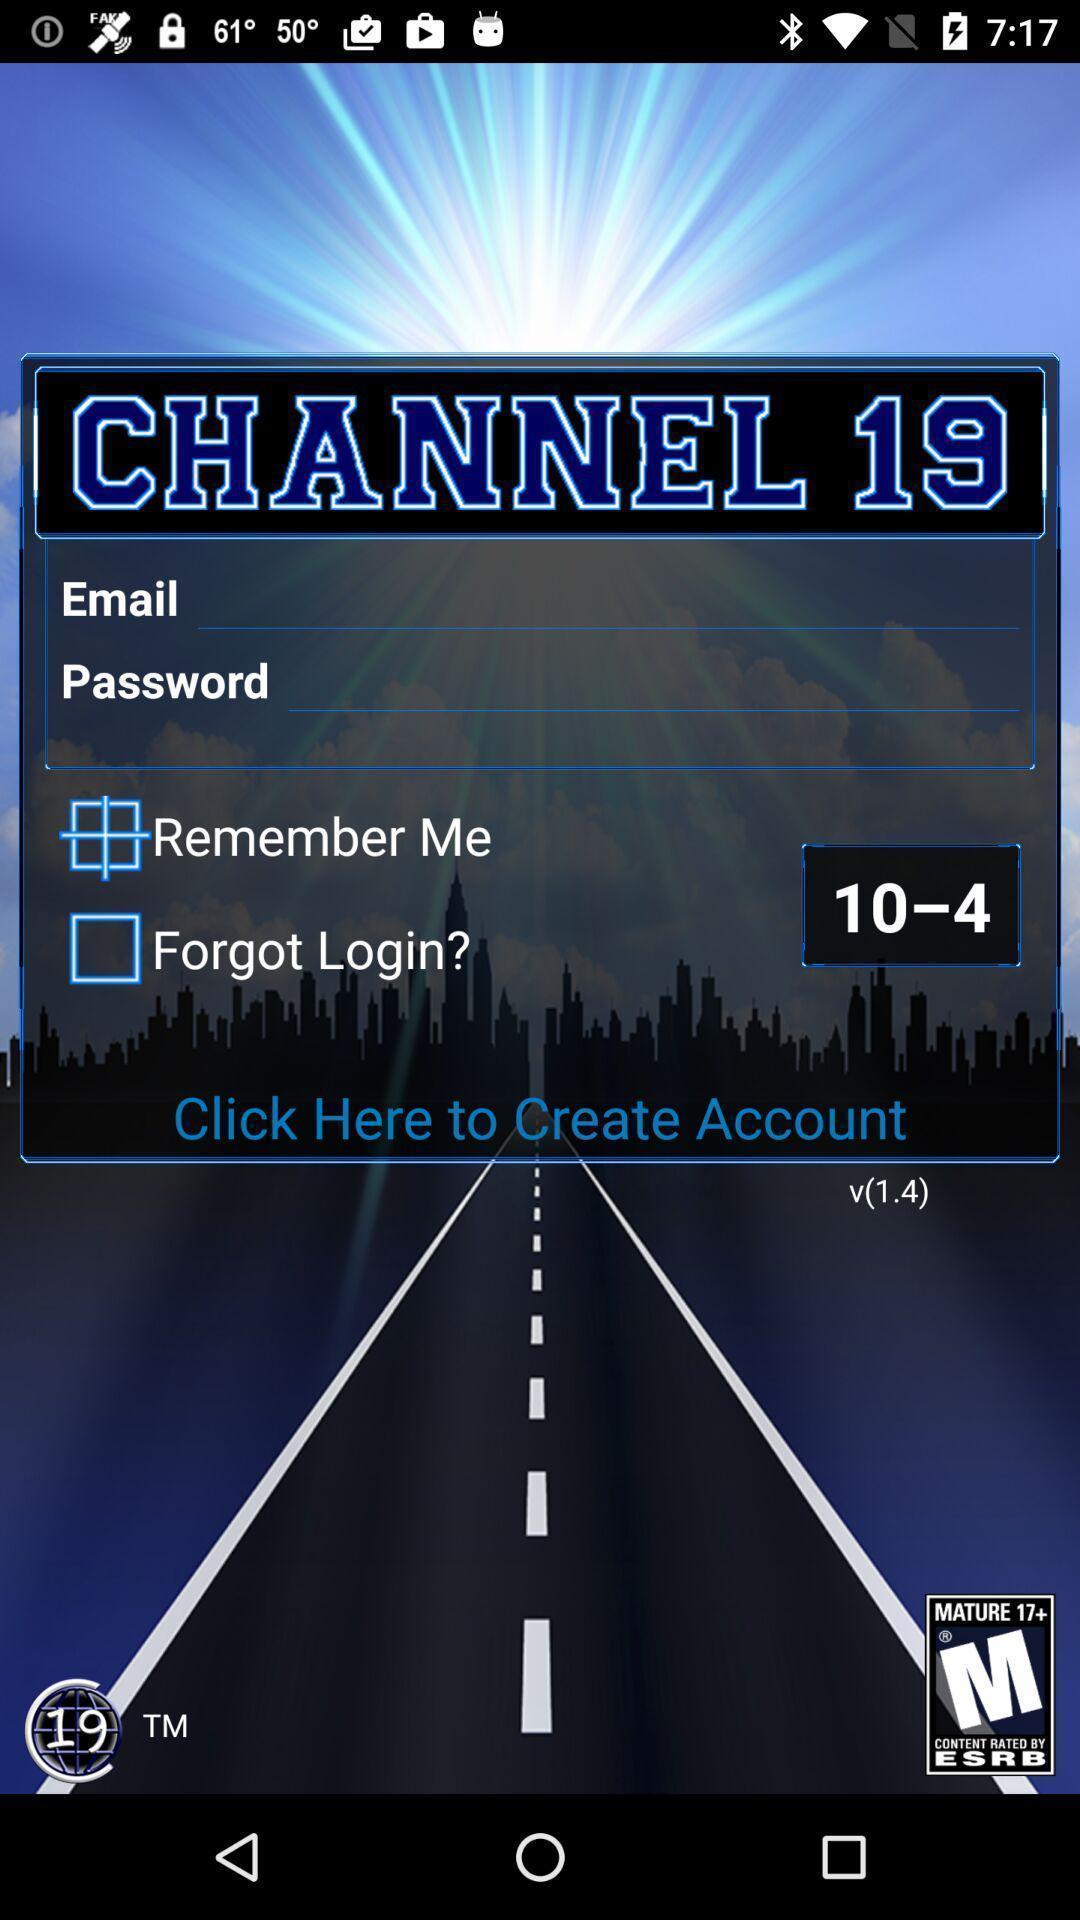Summarize the main components in this picture. Page showing login page option. 